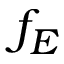<formula> <loc_0><loc_0><loc_500><loc_500>f _ { E }</formula> 